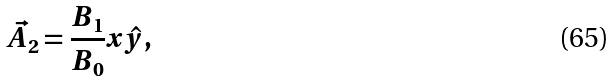Convert formula to latex. <formula><loc_0><loc_0><loc_500><loc_500>\vec { A _ { 2 } } = \frac { B _ { 1 } } { B _ { 0 } } x \hat { y } ,</formula> 